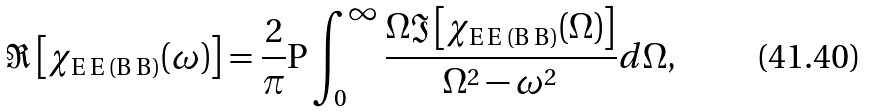<formula> <loc_0><loc_0><loc_500><loc_500>\Re \left [ \chi _ { \text {E\,E\,(B\,B)} } ( \omega ) \right ] = \frac { 2 } { \pi } \text {P} \int _ { 0 } ^ { \infty } \frac { \Omega \Im \left [ \chi _ { \text {E\,E\,(B\,B)} } ( \Omega ) \right ] } { \Omega ^ { 2 } - \omega ^ { 2 } } d \Omega ,</formula> 